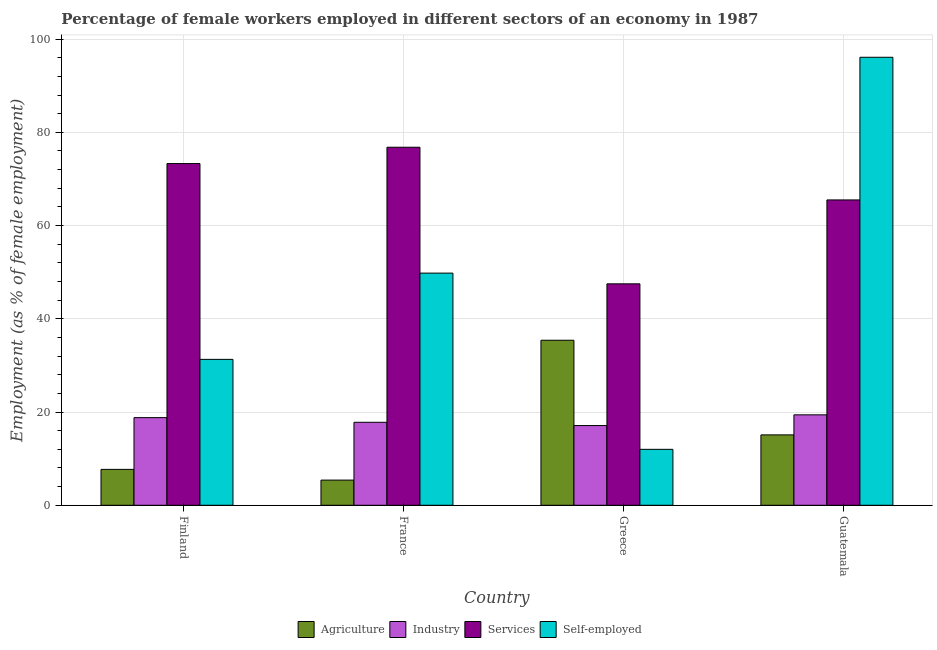How many different coloured bars are there?
Keep it short and to the point. 4. In how many cases, is the number of bars for a given country not equal to the number of legend labels?
Provide a short and direct response. 0. What is the percentage of female workers in services in France?
Keep it short and to the point. 76.8. Across all countries, what is the maximum percentage of self employed female workers?
Your answer should be compact. 96.1. Across all countries, what is the minimum percentage of female workers in industry?
Offer a terse response. 17.1. In which country was the percentage of female workers in agriculture maximum?
Your answer should be compact. Greece. In which country was the percentage of self employed female workers minimum?
Ensure brevity in your answer.  Greece. What is the total percentage of female workers in services in the graph?
Give a very brief answer. 263.1. What is the difference between the percentage of female workers in industry in France and that in Greece?
Make the answer very short. 0.7. What is the difference between the percentage of female workers in agriculture in Guatemala and the percentage of female workers in services in Greece?
Keep it short and to the point. -32.4. What is the average percentage of female workers in services per country?
Your answer should be compact. 65.78. What is the difference between the percentage of female workers in agriculture and percentage of female workers in services in Finland?
Provide a succinct answer. -65.6. What is the ratio of the percentage of female workers in services in Greece to that in Guatemala?
Keep it short and to the point. 0.73. What is the difference between the highest and the second highest percentage of female workers in industry?
Your response must be concise. 0.6. What is the difference between the highest and the lowest percentage of female workers in agriculture?
Provide a short and direct response. 30. In how many countries, is the percentage of female workers in agriculture greater than the average percentage of female workers in agriculture taken over all countries?
Your answer should be very brief. 1. Is it the case that in every country, the sum of the percentage of female workers in agriculture and percentage of female workers in industry is greater than the sum of percentage of self employed female workers and percentage of female workers in services?
Offer a very short reply. No. What does the 4th bar from the left in Finland represents?
Provide a succinct answer. Self-employed. What does the 2nd bar from the right in France represents?
Your answer should be compact. Services. Does the graph contain any zero values?
Your answer should be compact. No. Does the graph contain grids?
Your answer should be very brief. Yes. Where does the legend appear in the graph?
Make the answer very short. Bottom center. How many legend labels are there?
Offer a terse response. 4. What is the title of the graph?
Your response must be concise. Percentage of female workers employed in different sectors of an economy in 1987. What is the label or title of the Y-axis?
Your answer should be compact. Employment (as % of female employment). What is the Employment (as % of female employment) in Agriculture in Finland?
Ensure brevity in your answer.  7.7. What is the Employment (as % of female employment) of Industry in Finland?
Your response must be concise. 18.8. What is the Employment (as % of female employment) of Services in Finland?
Give a very brief answer. 73.3. What is the Employment (as % of female employment) in Self-employed in Finland?
Ensure brevity in your answer.  31.3. What is the Employment (as % of female employment) in Agriculture in France?
Provide a succinct answer. 5.4. What is the Employment (as % of female employment) of Industry in France?
Ensure brevity in your answer.  17.8. What is the Employment (as % of female employment) in Services in France?
Your answer should be compact. 76.8. What is the Employment (as % of female employment) of Self-employed in France?
Your answer should be compact. 49.8. What is the Employment (as % of female employment) in Agriculture in Greece?
Offer a very short reply. 35.4. What is the Employment (as % of female employment) in Industry in Greece?
Your response must be concise. 17.1. What is the Employment (as % of female employment) in Services in Greece?
Keep it short and to the point. 47.5. What is the Employment (as % of female employment) in Self-employed in Greece?
Your response must be concise. 12. What is the Employment (as % of female employment) of Agriculture in Guatemala?
Your response must be concise. 15.1. What is the Employment (as % of female employment) of Industry in Guatemala?
Give a very brief answer. 19.4. What is the Employment (as % of female employment) of Services in Guatemala?
Offer a very short reply. 65.5. What is the Employment (as % of female employment) of Self-employed in Guatemala?
Your answer should be very brief. 96.1. Across all countries, what is the maximum Employment (as % of female employment) in Agriculture?
Keep it short and to the point. 35.4. Across all countries, what is the maximum Employment (as % of female employment) in Industry?
Your response must be concise. 19.4. Across all countries, what is the maximum Employment (as % of female employment) in Services?
Your answer should be very brief. 76.8. Across all countries, what is the maximum Employment (as % of female employment) in Self-employed?
Give a very brief answer. 96.1. Across all countries, what is the minimum Employment (as % of female employment) in Agriculture?
Your answer should be very brief. 5.4. Across all countries, what is the minimum Employment (as % of female employment) of Industry?
Offer a very short reply. 17.1. Across all countries, what is the minimum Employment (as % of female employment) in Services?
Your answer should be very brief. 47.5. What is the total Employment (as % of female employment) in Agriculture in the graph?
Give a very brief answer. 63.6. What is the total Employment (as % of female employment) in Industry in the graph?
Provide a short and direct response. 73.1. What is the total Employment (as % of female employment) in Services in the graph?
Ensure brevity in your answer.  263.1. What is the total Employment (as % of female employment) in Self-employed in the graph?
Make the answer very short. 189.2. What is the difference between the Employment (as % of female employment) of Industry in Finland and that in France?
Provide a succinct answer. 1. What is the difference between the Employment (as % of female employment) in Services in Finland and that in France?
Your response must be concise. -3.5. What is the difference between the Employment (as % of female employment) in Self-employed in Finland and that in France?
Your answer should be very brief. -18.5. What is the difference between the Employment (as % of female employment) of Agriculture in Finland and that in Greece?
Keep it short and to the point. -27.7. What is the difference between the Employment (as % of female employment) in Services in Finland and that in Greece?
Provide a short and direct response. 25.8. What is the difference between the Employment (as % of female employment) in Self-employed in Finland and that in Greece?
Offer a terse response. 19.3. What is the difference between the Employment (as % of female employment) of Industry in Finland and that in Guatemala?
Provide a succinct answer. -0.6. What is the difference between the Employment (as % of female employment) of Services in Finland and that in Guatemala?
Your response must be concise. 7.8. What is the difference between the Employment (as % of female employment) of Self-employed in Finland and that in Guatemala?
Provide a short and direct response. -64.8. What is the difference between the Employment (as % of female employment) of Agriculture in France and that in Greece?
Your response must be concise. -30. What is the difference between the Employment (as % of female employment) in Industry in France and that in Greece?
Make the answer very short. 0.7. What is the difference between the Employment (as % of female employment) in Services in France and that in Greece?
Your answer should be compact. 29.3. What is the difference between the Employment (as % of female employment) of Self-employed in France and that in Greece?
Provide a succinct answer. 37.8. What is the difference between the Employment (as % of female employment) in Agriculture in France and that in Guatemala?
Your response must be concise. -9.7. What is the difference between the Employment (as % of female employment) of Services in France and that in Guatemala?
Your answer should be compact. 11.3. What is the difference between the Employment (as % of female employment) in Self-employed in France and that in Guatemala?
Offer a very short reply. -46.3. What is the difference between the Employment (as % of female employment) of Agriculture in Greece and that in Guatemala?
Offer a very short reply. 20.3. What is the difference between the Employment (as % of female employment) in Services in Greece and that in Guatemala?
Ensure brevity in your answer.  -18. What is the difference between the Employment (as % of female employment) of Self-employed in Greece and that in Guatemala?
Make the answer very short. -84.1. What is the difference between the Employment (as % of female employment) in Agriculture in Finland and the Employment (as % of female employment) in Industry in France?
Offer a very short reply. -10.1. What is the difference between the Employment (as % of female employment) of Agriculture in Finland and the Employment (as % of female employment) of Services in France?
Ensure brevity in your answer.  -69.1. What is the difference between the Employment (as % of female employment) of Agriculture in Finland and the Employment (as % of female employment) of Self-employed in France?
Give a very brief answer. -42.1. What is the difference between the Employment (as % of female employment) of Industry in Finland and the Employment (as % of female employment) of Services in France?
Ensure brevity in your answer.  -58. What is the difference between the Employment (as % of female employment) of Industry in Finland and the Employment (as % of female employment) of Self-employed in France?
Ensure brevity in your answer.  -31. What is the difference between the Employment (as % of female employment) in Agriculture in Finland and the Employment (as % of female employment) in Services in Greece?
Offer a terse response. -39.8. What is the difference between the Employment (as % of female employment) of Industry in Finland and the Employment (as % of female employment) of Services in Greece?
Provide a short and direct response. -28.7. What is the difference between the Employment (as % of female employment) of Services in Finland and the Employment (as % of female employment) of Self-employed in Greece?
Give a very brief answer. 61.3. What is the difference between the Employment (as % of female employment) of Agriculture in Finland and the Employment (as % of female employment) of Services in Guatemala?
Your answer should be compact. -57.8. What is the difference between the Employment (as % of female employment) of Agriculture in Finland and the Employment (as % of female employment) of Self-employed in Guatemala?
Make the answer very short. -88.4. What is the difference between the Employment (as % of female employment) of Industry in Finland and the Employment (as % of female employment) of Services in Guatemala?
Your answer should be very brief. -46.7. What is the difference between the Employment (as % of female employment) of Industry in Finland and the Employment (as % of female employment) of Self-employed in Guatemala?
Give a very brief answer. -77.3. What is the difference between the Employment (as % of female employment) of Services in Finland and the Employment (as % of female employment) of Self-employed in Guatemala?
Offer a terse response. -22.8. What is the difference between the Employment (as % of female employment) of Agriculture in France and the Employment (as % of female employment) of Services in Greece?
Your response must be concise. -42.1. What is the difference between the Employment (as % of female employment) in Industry in France and the Employment (as % of female employment) in Services in Greece?
Your answer should be compact. -29.7. What is the difference between the Employment (as % of female employment) of Services in France and the Employment (as % of female employment) of Self-employed in Greece?
Ensure brevity in your answer.  64.8. What is the difference between the Employment (as % of female employment) in Agriculture in France and the Employment (as % of female employment) in Industry in Guatemala?
Your response must be concise. -14. What is the difference between the Employment (as % of female employment) in Agriculture in France and the Employment (as % of female employment) in Services in Guatemala?
Offer a very short reply. -60.1. What is the difference between the Employment (as % of female employment) in Agriculture in France and the Employment (as % of female employment) in Self-employed in Guatemala?
Your response must be concise. -90.7. What is the difference between the Employment (as % of female employment) in Industry in France and the Employment (as % of female employment) in Services in Guatemala?
Your answer should be very brief. -47.7. What is the difference between the Employment (as % of female employment) of Industry in France and the Employment (as % of female employment) of Self-employed in Guatemala?
Provide a succinct answer. -78.3. What is the difference between the Employment (as % of female employment) in Services in France and the Employment (as % of female employment) in Self-employed in Guatemala?
Your answer should be very brief. -19.3. What is the difference between the Employment (as % of female employment) of Agriculture in Greece and the Employment (as % of female employment) of Services in Guatemala?
Keep it short and to the point. -30.1. What is the difference between the Employment (as % of female employment) of Agriculture in Greece and the Employment (as % of female employment) of Self-employed in Guatemala?
Provide a succinct answer. -60.7. What is the difference between the Employment (as % of female employment) of Industry in Greece and the Employment (as % of female employment) of Services in Guatemala?
Keep it short and to the point. -48.4. What is the difference between the Employment (as % of female employment) of Industry in Greece and the Employment (as % of female employment) of Self-employed in Guatemala?
Offer a very short reply. -79. What is the difference between the Employment (as % of female employment) of Services in Greece and the Employment (as % of female employment) of Self-employed in Guatemala?
Your response must be concise. -48.6. What is the average Employment (as % of female employment) in Agriculture per country?
Your response must be concise. 15.9. What is the average Employment (as % of female employment) of Industry per country?
Keep it short and to the point. 18.27. What is the average Employment (as % of female employment) in Services per country?
Keep it short and to the point. 65.78. What is the average Employment (as % of female employment) of Self-employed per country?
Your answer should be very brief. 47.3. What is the difference between the Employment (as % of female employment) in Agriculture and Employment (as % of female employment) in Industry in Finland?
Offer a very short reply. -11.1. What is the difference between the Employment (as % of female employment) of Agriculture and Employment (as % of female employment) of Services in Finland?
Ensure brevity in your answer.  -65.6. What is the difference between the Employment (as % of female employment) of Agriculture and Employment (as % of female employment) of Self-employed in Finland?
Give a very brief answer. -23.6. What is the difference between the Employment (as % of female employment) of Industry and Employment (as % of female employment) of Services in Finland?
Give a very brief answer. -54.5. What is the difference between the Employment (as % of female employment) in Industry and Employment (as % of female employment) in Self-employed in Finland?
Ensure brevity in your answer.  -12.5. What is the difference between the Employment (as % of female employment) in Services and Employment (as % of female employment) in Self-employed in Finland?
Offer a very short reply. 42. What is the difference between the Employment (as % of female employment) in Agriculture and Employment (as % of female employment) in Industry in France?
Ensure brevity in your answer.  -12.4. What is the difference between the Employment (as % of female employment) of Agriculture and Employment (as % of female employment) of Services in France?
Your answer should be compact. -71.4. What is the difference between the Employment (as % of female employment) of Agriculture and Employment (as % of female employment) of Self-employed in France?
Ensure brevity in your answer.  -44.4. What is the difference between the Employment (as % of female employment) in Industry and Employment (as % of female employment) in Services in France?
Provide a short and direct response. -59. What is the difference between the Employment (as % of female employment) in Industry and Employment (as % of female employment) in Self-employed in France?
Provide a short and direct response. -32. What is the difference between the Employment (as % of female employment) of Agriculture and Employment (as % of female employment) of Self-employed in Greece?
Your answer should be very brief. 23.4. What is the difference between the Employment (as % of female employment) of Industry and Employment (as % of female employment) of Services in Greece?
Your response must be concise. -30.4. What is the difference between the Employment (as % of female employment) in Industry and Employment (as % of female employment) in Self-employed in Greece?
Provide a short and direct response. 5.1. What is the difference between the Employment (as % of female employment) of Services and Employment (as % of female employment) of Self-employed in Greece?
Provide a succinct answer. 35.5. What is the difference between the Employment (as % of female employment) of Agriculture and Employment (as % of female employment) of Services in Guatemala?
Keep it short and to the point. -50.4. What is the difference between the Employment (as % of female employment) in Agriculture and Employment (as % of female employment) in Self-employed in Guatemala?
Offer a very short reply. -81. What is the difference between the Employment (as % of female employment) in Industry and Employment (as % of female employment) in Services in Guatemala?
Offer a terse response. -46.1. What is the difference between the Employment (as % of female employment) of Industry and Employment (as % of female employment) of Self-employed in Guatemala?
Your response must be concise. -76.7. What is the difference between the Employment (as % of female employment) in Services and Employment (as % of female employment) in Self-employed in Guatemala?
Your answer should be very brief. -30.6. What is the ratio of the Employment (as % of female employment) in Agriculture in Finland to that in France?
Offer a very short reply. 1.43. What is the ratio of the Employment (as % of female employment) in Industry in Finland to that in France?
Make the answer very short. 1.06. What is the ratio of the Employment (as % of female employment) in Services in Finland to that in France?
Give a very brief answer. 0.95. What is the ratio of the Employment (as % of female employment) of Self-employed in Finland to that in France?
Your answer should be very brief. 0.63. What is the ratio of the Employment (as % of female employment) of Agriculture in Finland to that in Greece?
Your answer should be very brief. 0.22. What is the ratio of the Employment (as % of female employment) of Industry in Finland to that in Greece?
Provide a short and direct response. 1.1. What is the ratio of the Employment (as % of female employment) in Services in Finland to that in Greece?
Give a very brief answer. 1.54. What is the ratio of the Employment (as % of female employment) in Self-employed in Finland to that in Greece?
Ensure brevity in your answer.  2.61. What is the ratio of the Employment (as % of female employment) of Agriculture in Finland to that in Guatemala?
Offer a very short reply. 0.51. What is the ratio of the Employment (as % of female employment) of Industry in Finland to that in Guatemala?
Offer a very short reply. 0.97. What is the ratio of the Employment (as % of female employment) of Services in Finland to that in Guatemala?
Your answer should be very brief. 1.12. What is the ratio of the Employment (as % of female employment) of Self-employed in Finland to that in Guatemala?
Provide a succinct answer. 0.33. What is the ratio of the Employment (as % of female employment) in Agriculture in France to that in Greece?
Offer a terse response. 0.15. What is the ratio of the Employment (as % of female employment) in Industry in France to that in Greece?
Make the answer very short. 1.04. What is the ratio of the Employment (as % of female employment) of Services in France to that in Greece?
Keep it short and to the point. 1.62. What is the ratio of the Employment (as % of female employment) of Self-employed in France to that in Greece?
Ensure brevity in your answer.  4.15. What is the ratio of the Employment (as % of female employment) of Agriculture in France to that in Guatemala?
Ensure brevity in your answer.  0.36. What is the ratio of the Employment (as % of female employment) of Industry in France to that in Guatemala?
Provide a short and direct response. 0.92. What is the ratio of the Employment (as % of female employment) of Services in France to that in Guatemala?
Offer a very short reply. 1.17. What is the ratio of the Employment (as % of female employment) of Self-employed in France to that in Guatemala?
Offer a very short reply. 0.52. What is the ratio of the Employment (as % of female employment) of Agriculture in Greece to that in Guatemala?
Offer a terse response. 2.34. What is the ratio of the Employment (as % of female employment) of Industry in Greece to that in Guatemala?
Keep it short and to the point. 0.88. What is the ratio of the Employment (as % of female employment) of Services in Greece to that in Guatemala?
Provide a succinct answer. 0.73. What is the ratio of the Employment (as % of female employment) in Self-employed in Greece to that in Guatemala?
Offer a very short reply. 0.12. What is the difference between the highest and the second highest Employment (as % of female employment) in Agriculture?
Ensure brevity in your answer.  20.3. What is the difference between the highest and the second highest Employment (as % of female employment) of Services?
Your answer should be very brief. 3.5. What is the difference between the highest and the second highest Employment (as % of female employment) of Self-employed?
Give a very brief answer. 46.3. What is the difference between the highest and the lowest Employment (as % of female employment) in Industry?
Give a very brief answer. 2.3. What is the difference between the highest and the lowest Employment (as % of female employment) in Services?
Offer a terse response. 29.3. What is the difference between the highest and the lowest Employment (as % of female employment) of Self-employed?
Provide a succinct answer. 84.1. 